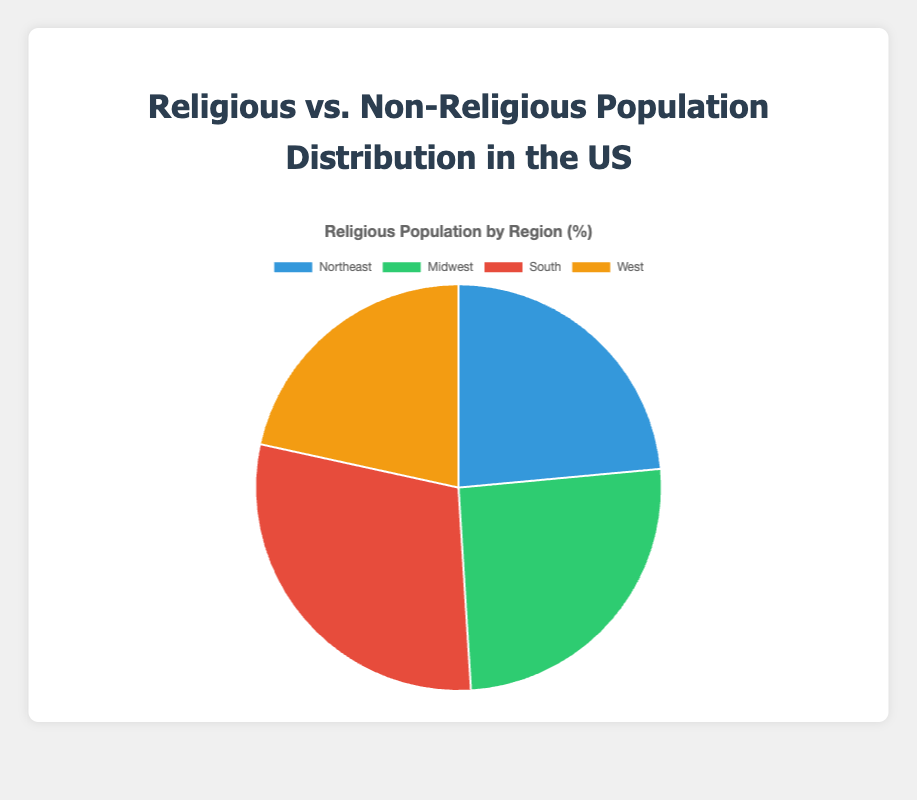What percentage of the population in the South is religious? According to the pie chart, the percentage of the religious population in the South is given. The chart indicates that 75% of the population in the South is religious.
Answer: 75% Which region has the highest percentage of non-religious population? To determine this, look at each region's percentages. The West has the highest non-religious population at 45%.
Answer: West What is the total percentage of religious population across all regions? Sum the percentages of the religious population in all regions: 60 (Northeast) + 65 (Midwest) + 75 (South) + 55 (West) = 255. Since there are four regions, this represents the total across these four regions.
Answer: 255% How many percentage points higher is the religious population in the South compared to the Midwest? Subtract the percentage of the Midwest religious population from the South's: 75 (South) - 65 (Midwest) = 10 percentage points.
Answer: 10 percentage points Which region has the smallest religious population percentage, and what is that percentage? Compare the religious population percentages across all regions. The West has the smallest religious population percentage at 55%.
Answer: West, 55% What is the average percentage of the non-religious population across the regions? Calculate the average percentage by summing the non-religious population percentages and dividing by the number of regions: (40 + 35 + 25 + 45) / 4 = 36.25%.
Answer: 36.25% Between the Northeast and the Midwest, which region has a greater proportion of the non-religious population? Compare the non-religious percentages: the Northeast has 40%, and the Midwest has 35%. The Northeast has a greater proportion of the non-religious population.
Answer: Northeast If you combine the non-religious populations of the Northeast and the West, what percentage do you get? Add the non-religious populations of the Northeast (40%) and the West (45%): 40 + 45 = 85%.
Answer: 85% Which region's religious population percentage is closest to the overall average percentage of the religious population? First, calculate the average percentage of the religious population: (60 + 65 + 75 + 55) / 4 = 63.75%. The Midwest's 65% is closest to this average.
Answer: Midwest, 65% If the West had the same percentage of the religious population as the South, how would that change the total religious percentage across all regions? The South's religious percentage is 75%. If the West also had 75%, add this to the total: 255 - 55 (West's original) + 75 = 275%.
Answer: 275% 